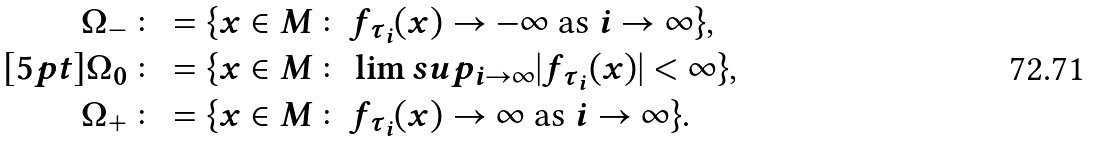Convert formula to latex. <formula><loc_0><loc_0><loc_500><loc_500>\Omega _ { - } & \colon = \{ x \in M \colon f _ { \tau _ { i } } ( x ) \to - \infty \ \text {as} \ i \to \infty \} , \\ [ 5 p t ] \Omega _ { 0 } & \colon = \{ x \in M \colon \lim s u p _ { i \to \infty } | f _ { \tau _ { i } } ( x ) | < \infty \} , \\ \Omega _ { + } & \colon = \{ x \in M \colon f _ { \tau _ { i } } ( x ) \to \infty \ \text {as} \ i \to \infty \} .</formula> 